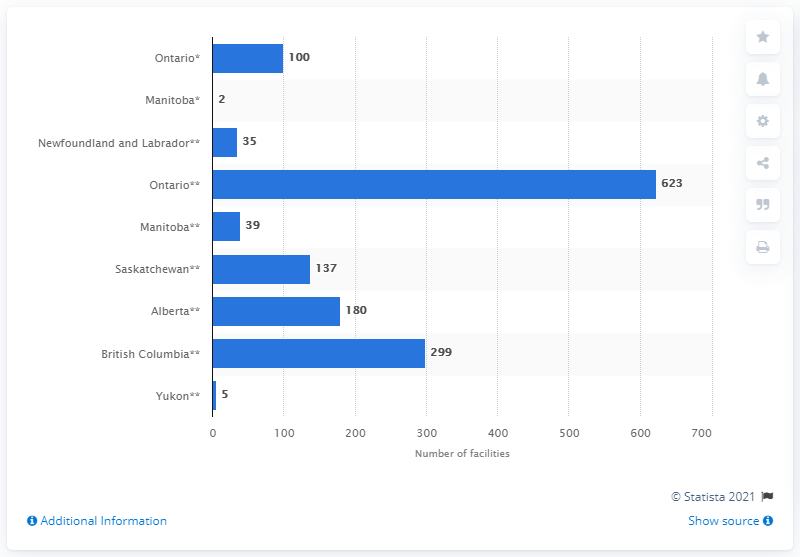Point out several critical features in this image. In fiscal year 2019-2020, there were 623 residential care facilities in Ontario. There are 100 hospital-based continuing care facilities in the province of Ontario. 